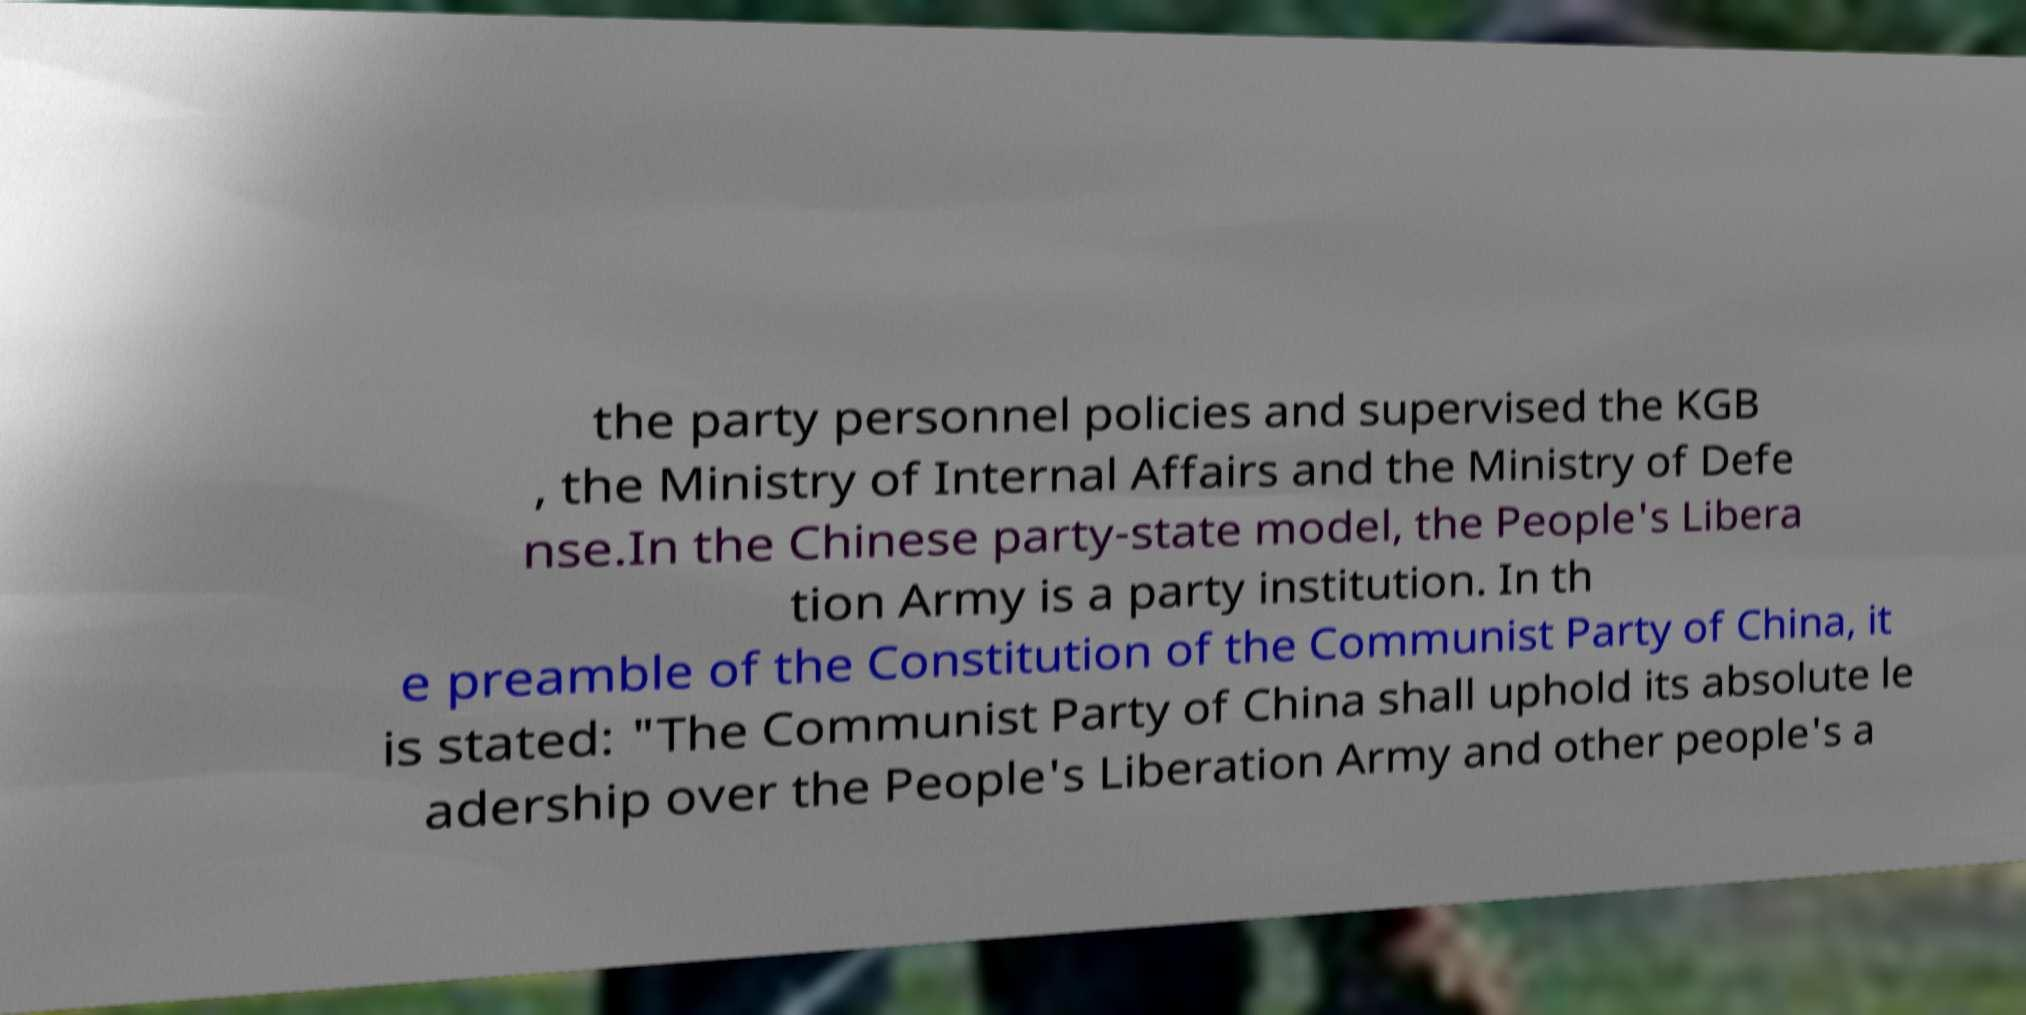There's text embedded in this image that I need extracted. Can you transcribe it verbatim? the party personnel policies and supervised the KGB , the Ministry of Internal Affairs and the Ministry of Defe nse.In the Chinese party-state model, the People's Libera tion Army is a party institution. In th e preamble of the Constitution of the Communist Party of China, it is stated: "The Communist Party of China shall uphold its absolute le adership over the People's Liberation Army and other people's a 